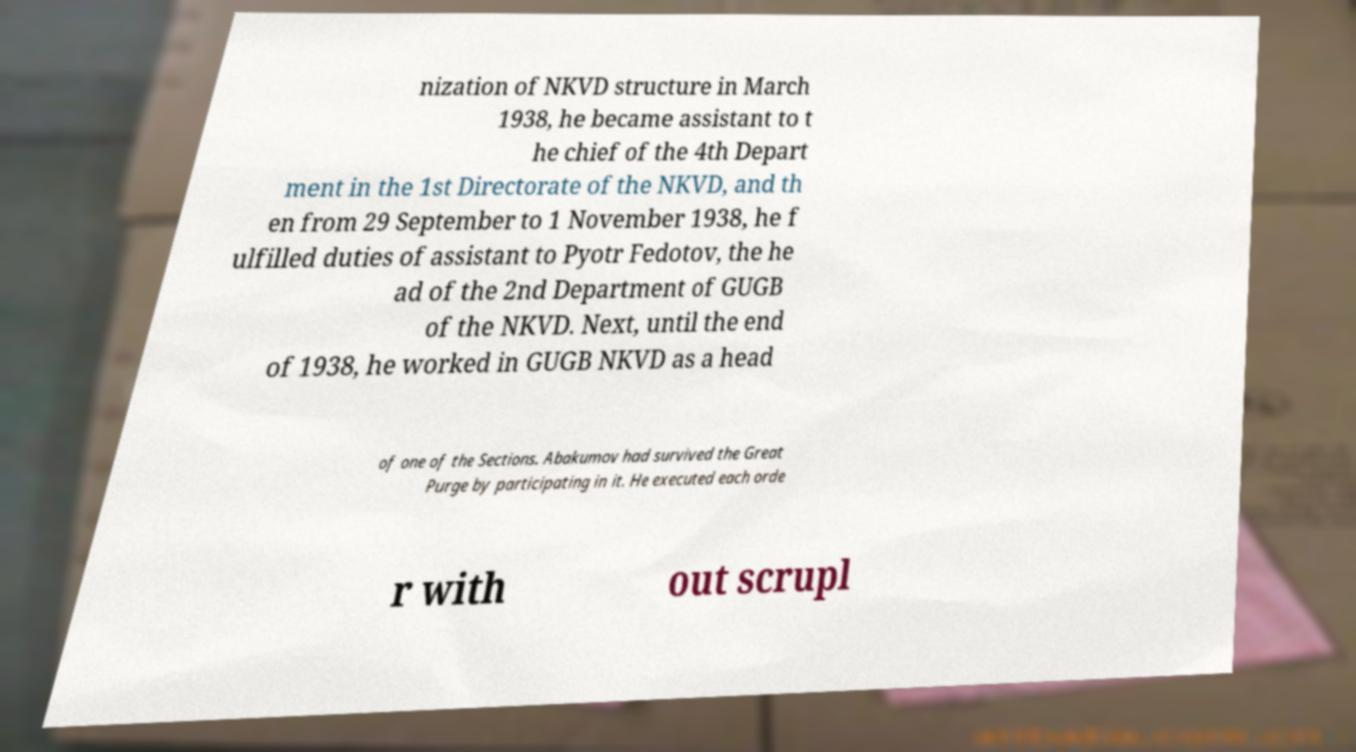Could you assist in decoding the text presented in this image and type it out clearly? nization of NKVD structure in March 1938, he became assistant to t he chief of the 4th Depart ment in the 1st Directorate of the NKVD, and th en from 29 September to 1 November 1938, he f ulfilled duties of assistant to Pyotr Fedotov, the he ad of the 2nd Department of GUGB of the NKVD. Next, until the end of 1938, he worked in GUGB NKVD as a head of one of the Sections. Abakumov had survived the Great Purge by participating in it. He executed each orde r with out scrupl 